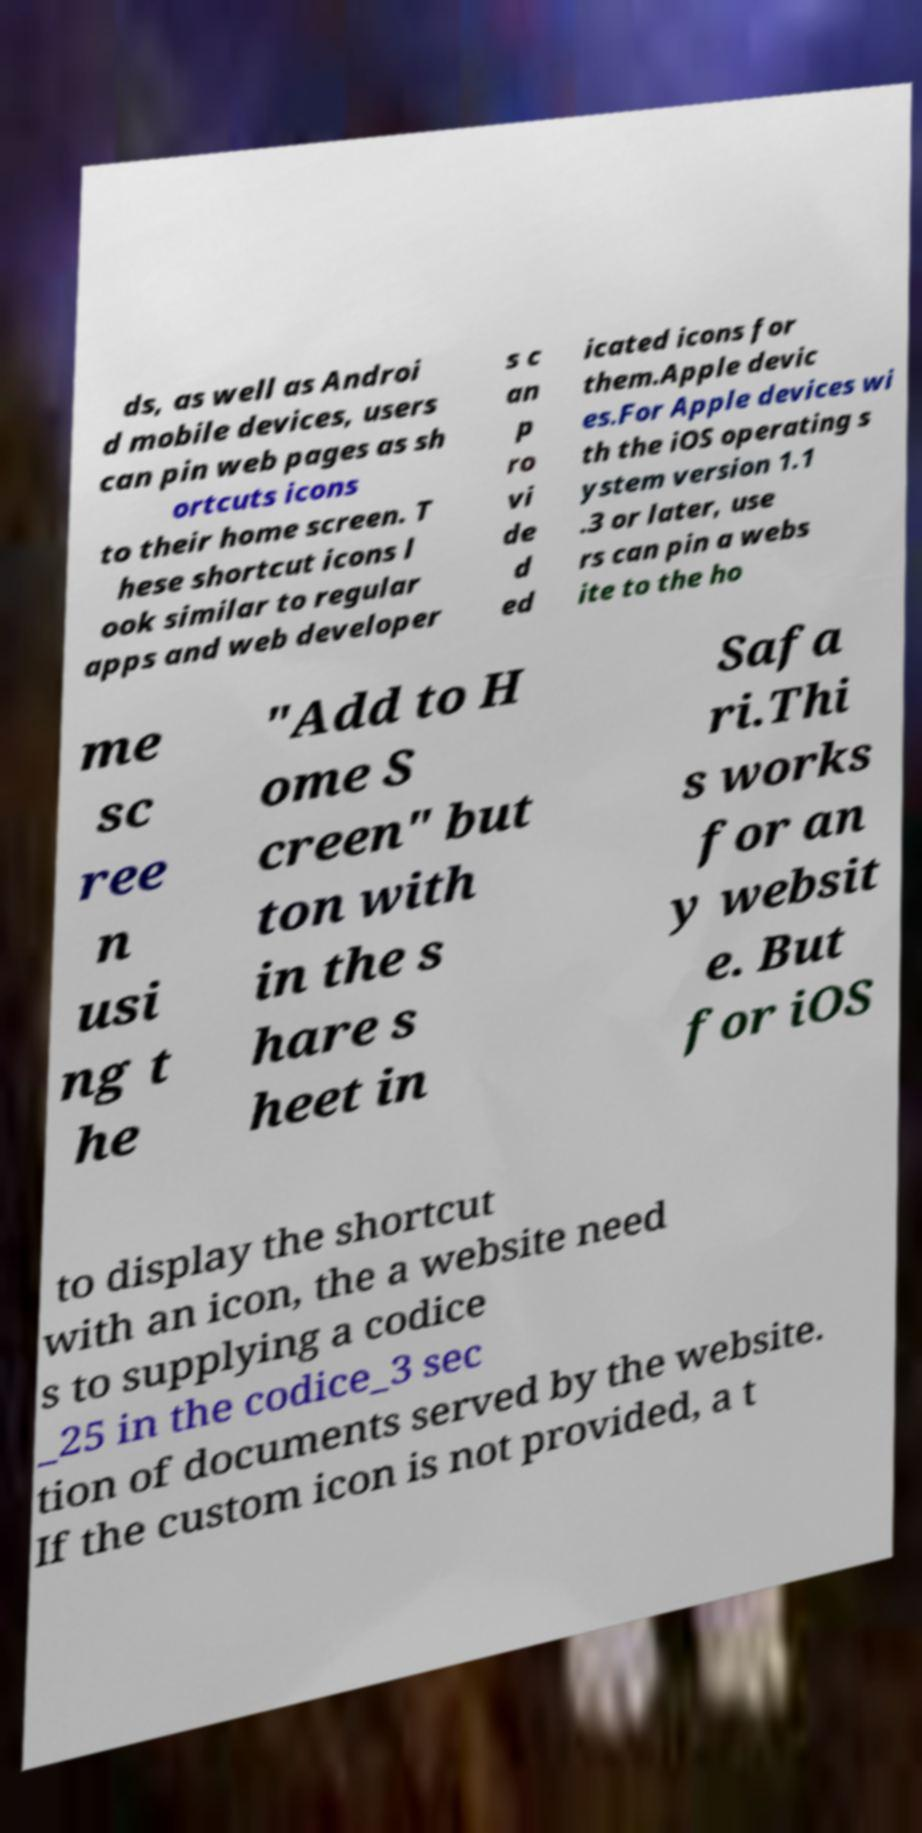For documentation purposes, I need the text within this image transcribed. Could you provide that? ds, as well as Androi d mobile devices, users can pin web pages as sh ortcuts icons to their home screen. T hese shortcut icons l ook similar to regular apps and web developer s c an p ro vi de d ed icated icons for them.Apple devic es.For Apple devices wi th the iOS operating s ystem version 1.1 .3 or later, use rs can pin a webs ite to the ho me sc ree n usi ng t he "Add to H ome S creen" but ton with in the s hare s heet in Safa ri.Thi s works for an y websit e. But for iOS to display the shortcut with an icon, the a website need s to supplying a codice _25 in the codice_3 sec tion of documents served by the website. If the custom icon is not provided, a t 